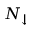Convert formula to latex. <formula><loc_0><loc_0><loc_500><loc_500>N _ { \downarrow }</formula> 